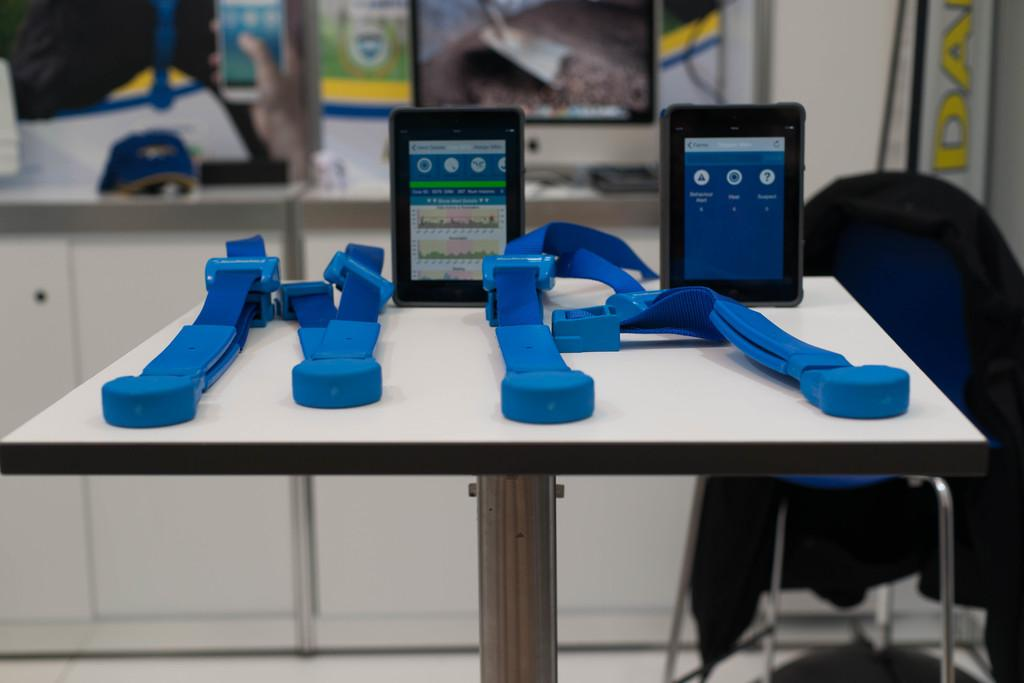What can be seen on the table in the foreground of the image? There are two screens and four belts on the table in the foreground. What type of furniture is present in the image? There is a chair in the image. What can be seen in the background of the image? There are cupboards, a monitor, and other unspecified items in the background. What is the monkey's reaction to the morning light in the image? There is no monkey present in the image, so it is not possible to determine its reaction to the morning light. 